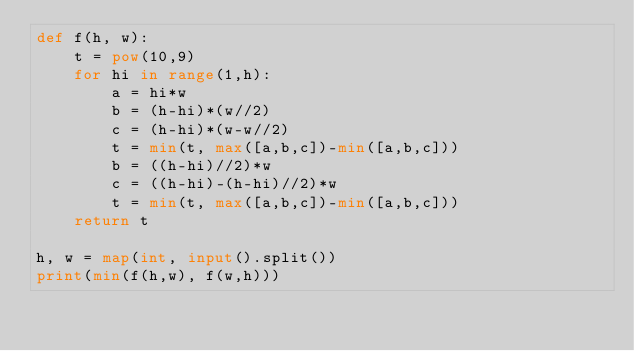Convert code to text. <code><loc_0><loc_0><loc_500><loc_500><_Python_>def f(h, w):
    t = pow(10,9)
    for hi in range(1,h):
        a = hi*w
        b = (h-hi)*(w//2)
        c = (h-hi)*(w-w//2)
        t = min(t, max([a,b,c])-min([a,b,c]))
        b = ((h-hi)//2)*w
        c = ((h-hi)-(h-hi)//2)*w
        t = min(t, max([a,b,c])-min([a,b,c]))
    return t

h, w = map(int, input().split())
print(min(f(h,w), f(w,h)))</code> 